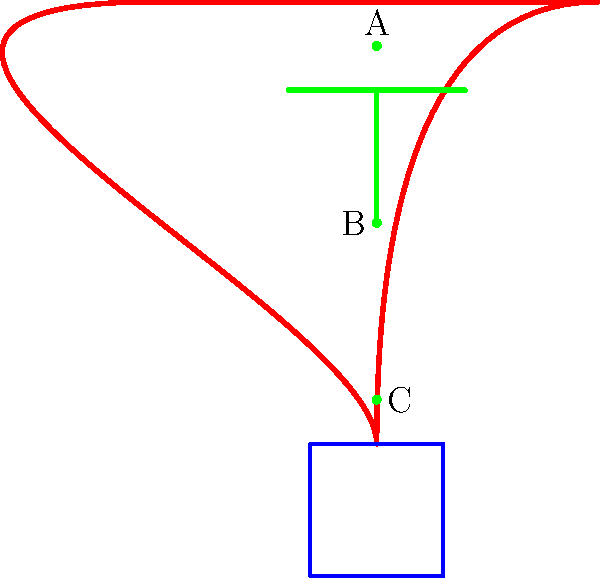In the diagram of a uterus, where should an intrauterine device (IUD) be correctly placed for optimal effectiveness? Select the best option: A, B, or C. To determine the correct placement of an IUD, let's follow these steps:

1. Understand the anatomy: The diagram shows a simplified version of the uterus (red) and cervix (blue). The green T-shaped object represents the IUD.

2. IUD placement principles:
   a) IUDs should be placed high in the uterine cavity.
   b) They should not be in contact with the cervix.
   c) The arms of the T-shape should be near the top of the uterus.

3. Analyze the options:
   A: Located at the very top of the uterus. This is the ideal position.
   B: Located in the middle of the uterus. This is too low for optimal effectiveness.
   C: Located near the cervix. This is much too low and could cause discomfort or expulsion.

4. Consider effectiveness and comfort:
   - Placement A allows the IUD to cover the widest area of the uterus.
   - Higher placement (A) reduces the risk of expulsion through the cervix.
   - Position A minimizes the chance of the IUD arms irritating the lower uterus or cervix.

5. Conclusion: Option A represents the correct placement for an IUD, ensuring maximum effectiveness and comfort.
Answer: A 